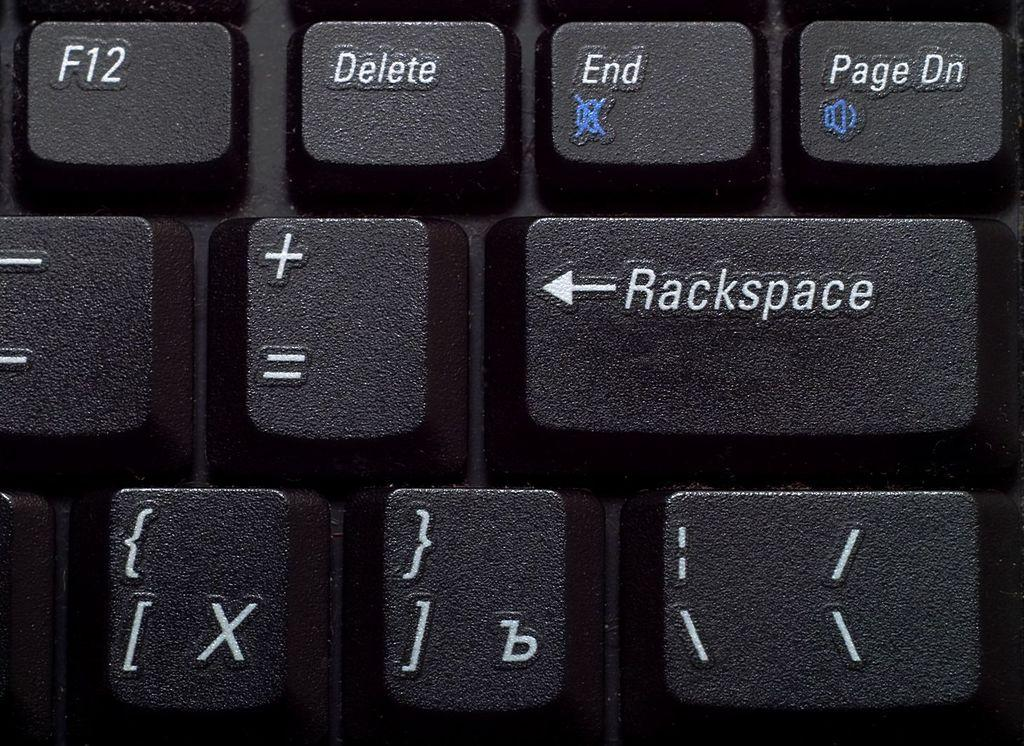<image>
Relay a brief, clear account of the picture shown. Black keyboard that shows a Rackspace key under the End key. 